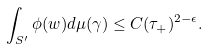<formula> <loc_0><loc_0><loc_500><loc_500>\int _ { S ^ { \prime } } \phi ( w ) d \mu ( \gamma ) \leq C ( \tau _ { + } ) ^ { 2 - \epsilon } .</formula> 